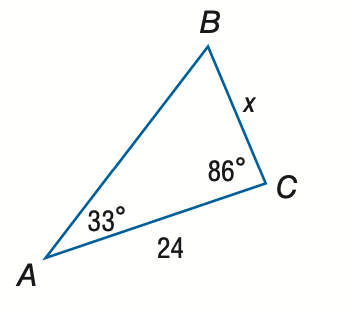Question: Find x. Round the side measure to the nearest tenth.
Choices:
A. 13.1
B. 14.9
C. 38.5
D. 44.0
Answer with the letter. Answer: B 